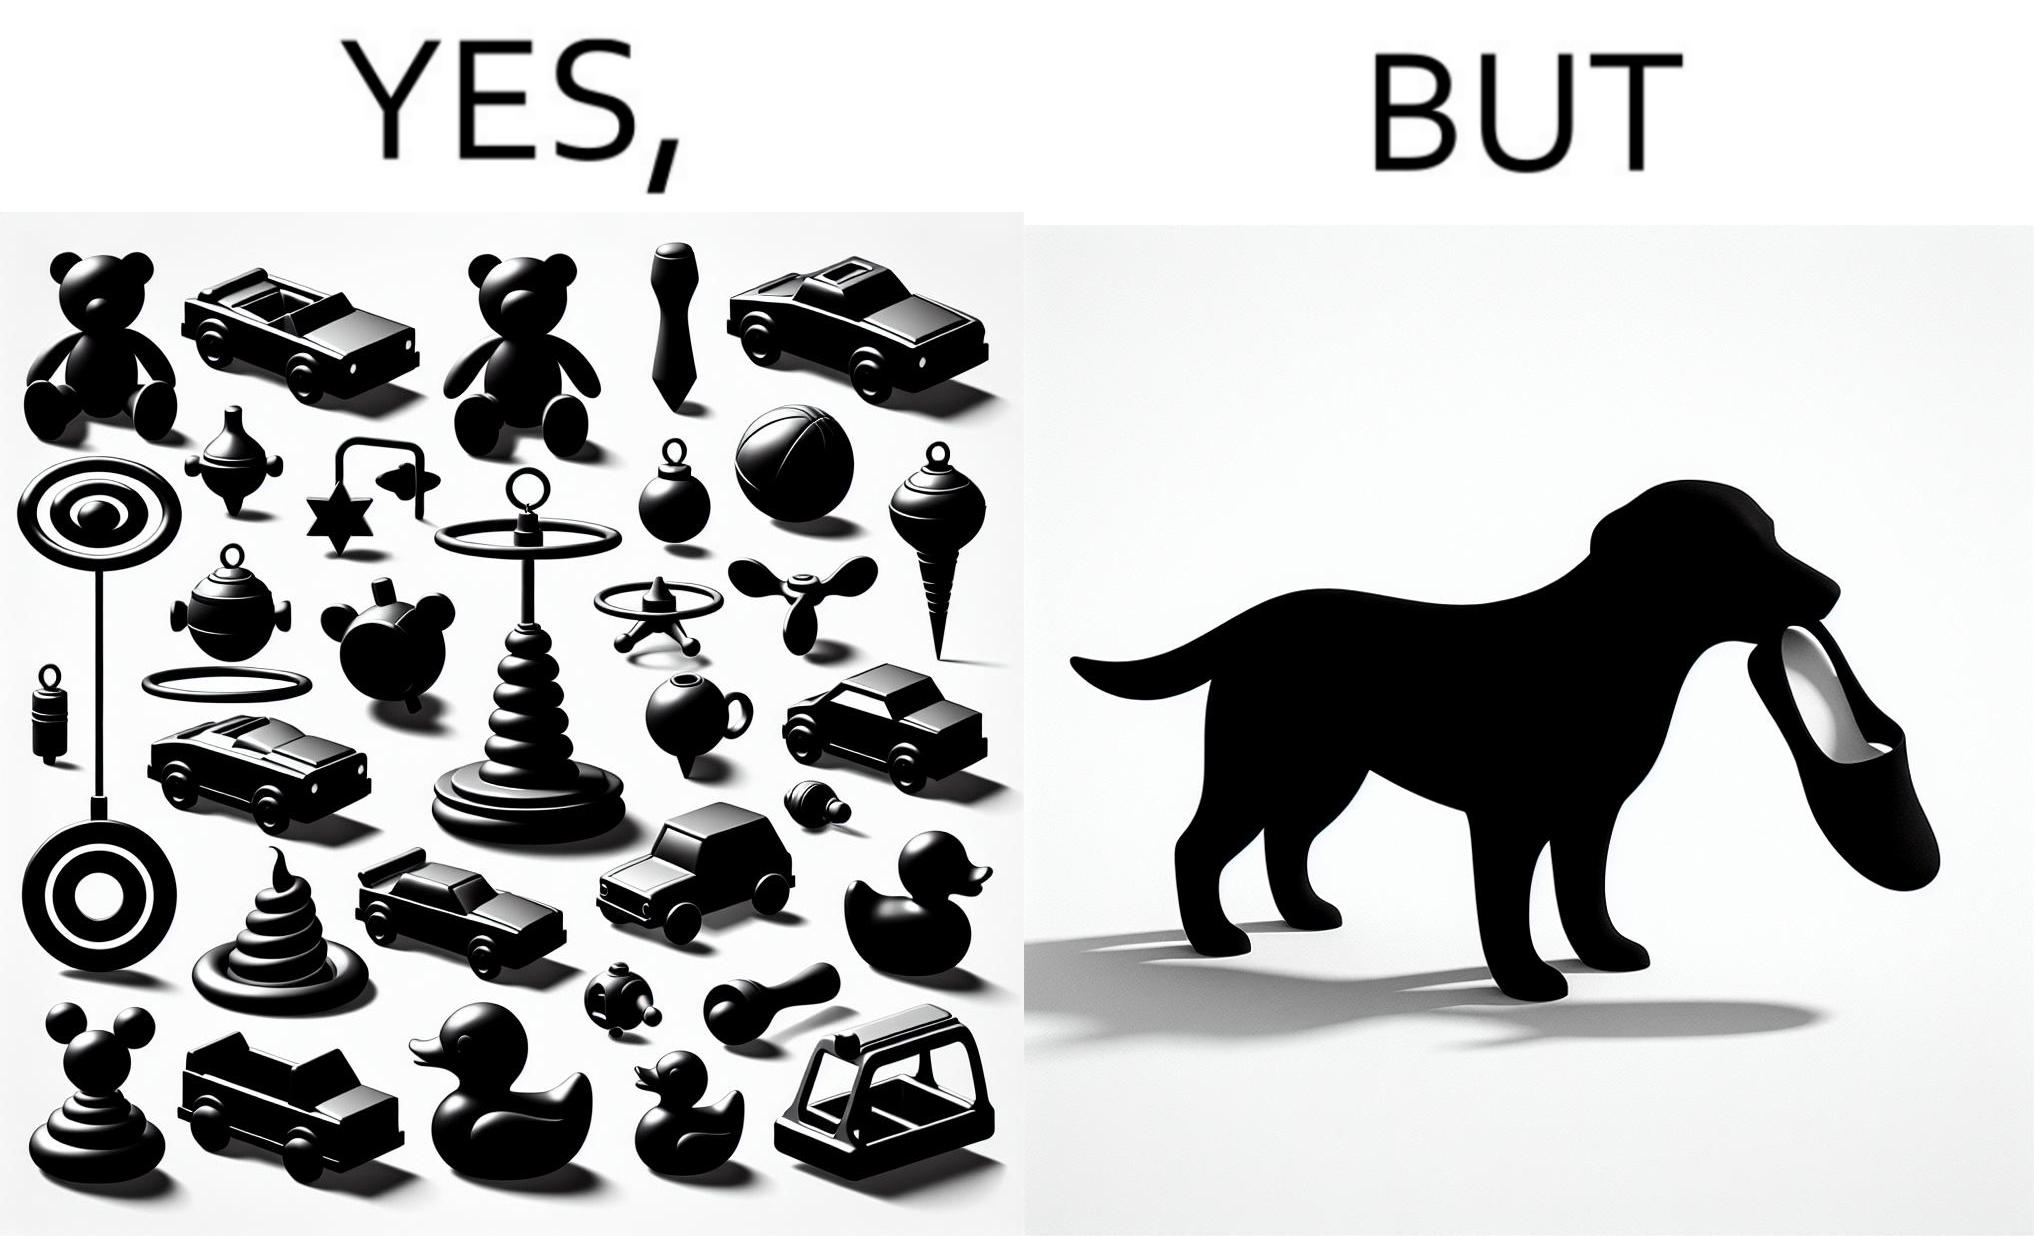What is the satirical meaning behind this image? the irony is that dog owners buy loads of toys for their dog but the dog's favourite toy is the owner's slippers 